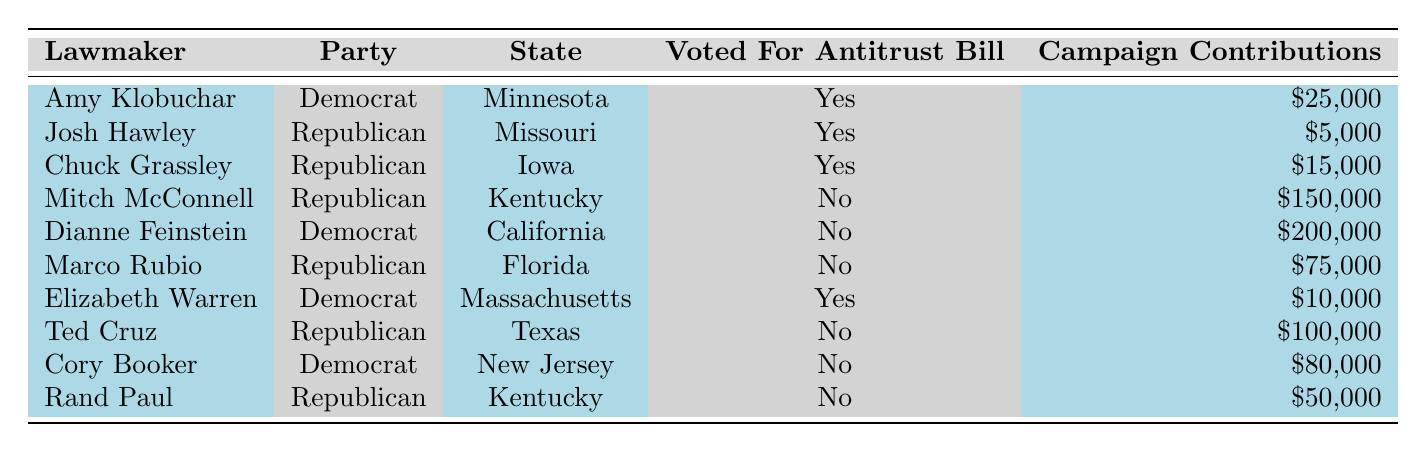What is the total amount of campaign contributions from lawmakers who voted for the antitrust bill? To calculate the total contributions from lawmakers who voted for the bill, identify those lawmakers first: Amy Klobuchar ($25,000), Josh Hawley ($5,000), Chuck Grassley ($15,000), and Elizabeth Warren ($10,000). Add these contributions: 25,000 + 5,000 + 15,000 + 10,000 = 55,000.
Answer: 55,000 How many Republicans voted for the antitrust bill? Review the table for Republican lawmakers and their votes. The Republican lawmakers who voted for the antitrust bill are Josh Hawley and Chuck Grassley. There are two of them.
Answer: 2 What was the maximum campaign contribution received by a lawmaker who opposed the antitrust bill? Look at the contributions of lawmakers who voted against the bill: Mitch McConnell ($150,000), Dianne Feinstein ($200,000), Marco Rubio ($75,000), Ted Cruz ($100,000), and Rand Paul ($50,000). The maximum contribution among these is $200,000 from Dianne Feinstein.
Answer: 200,000 Did Cory Booker vote for the antitrust bill? Check the table for Cory Booker's voting record. He is marked as "No" for voting for the antitrust bill.
Answer: No What is the average campaign contribution of lawmakers who voted against the antitrust bill? Identify the contributions of lawmakers who opposed the bill: Mitch McConnell ($150,000), Dianne Feinstein ($200,000), Marco Rubio ($75,000), Ted Cruz ($100,000), and Rand Paul ($50,000). There are 5 contributions. Calculate the sum: 150,000 + 200,000 + 75,000 + 100,000 + 50,000 = 575,000; divide by 5 to find the average: 575,000 / 5 = 115,000.
Answer: 115,000 How many Democrats voted against the antitrust bill? Look for Democrat lawmakers in the table who voted against the bill. Only Dianne Feinstein and Cory Booker are Democrats that voted "No," making the total 2.
Answer: 2 